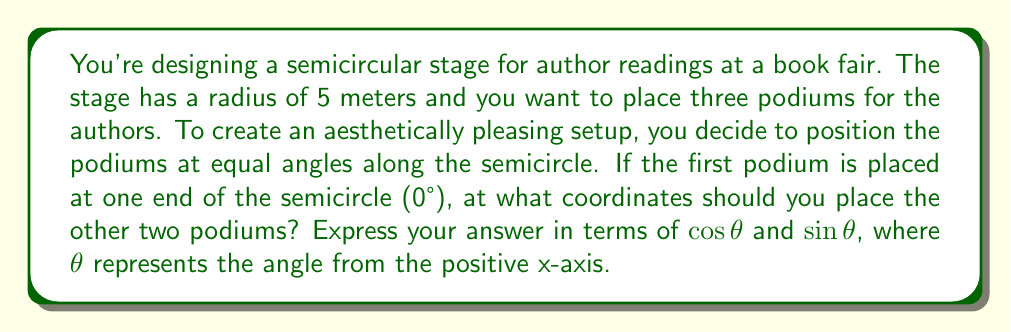Could you help me with this problem? Let's approach this step-by-step:

1) The semicircle spans 180°. To place three podiums at equal angles, we need to divide 180° by 3:

   $180° \div 3 = 60°$

2) So, our angles will be at 0°, 60°, and 120°.

3) We know that for a circle with radius $r$, the coordinates of a point at angle $\theta$ are given by:
   
   $(x, y) = (r \cos \theta, r \sin \theta)$

4) In this case, $r = 5$ meters.

5) For the first podium at 0°:
   $x = 5 \cos 0° = 5$
   $y = 5 \sin 0° = 0$
   Coordinates: $(5, 0)$

6) For the second podium at 60°:
   $x = 5 \cos 60° = 5 \cdot \frac{1}{2} = 2.5$
   $y = 5 \sin 60° = 5 \cdot \frac{\sqrt{3}}{2} = 5\frac{\sqrt{3}}{2}$
   Coordinates: $(2.5, 5\frac{\sqrt{3}}{2})$

7) For the third podium at 120°:
   $x = 5 \cos 120° = 5 \cdot (-\frac{1}{2}) = -2.5$
   $y = 5 \sin 120° = 5 \cdot \frac{\sqrt{3}}{2} = 5\frac{\sqrt{3}}{2}$
   Coordinates: $(-2.5, 5\frac{\sqrt{3}}{2})$
Answer: $(5, 0)$, $(2.5, 5\frac{\sqrt{3}}{2})$, $(-2.5, 5\frac{\sqrt{3}}{2})$ 